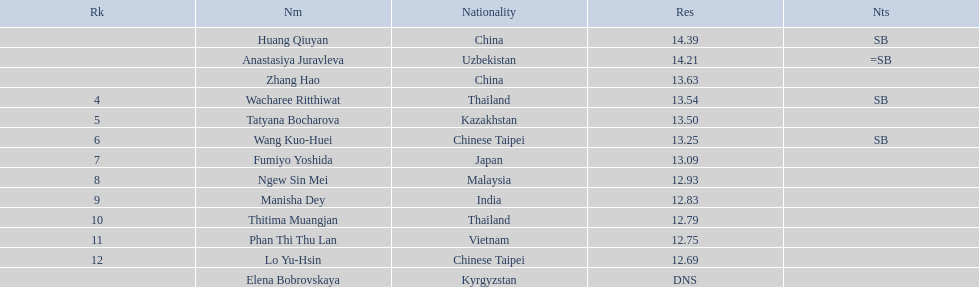Which country had the most competitors ranked in the top three in the event? China. 